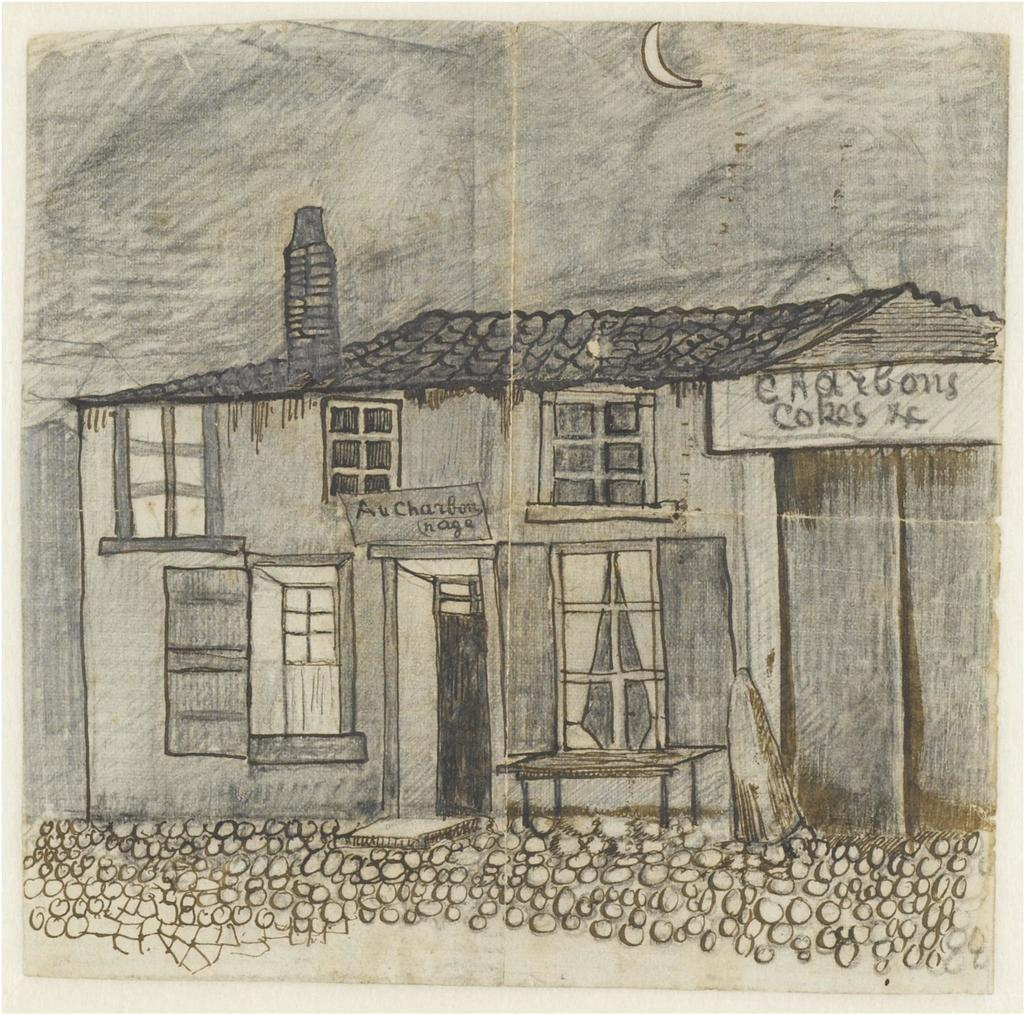What is depicted in the image? There is a drawing of a house in the image. What features can be seen on the house? The house has windows and a roof. What else is present in the image besides the house? There are sign boards with text in the image. What can be seen in the sky at the top of the image? The moon is visible in the sky. What type of question is being asked by the locket in the image? There is no locket present in the image, and therefore no such question can be asked. 